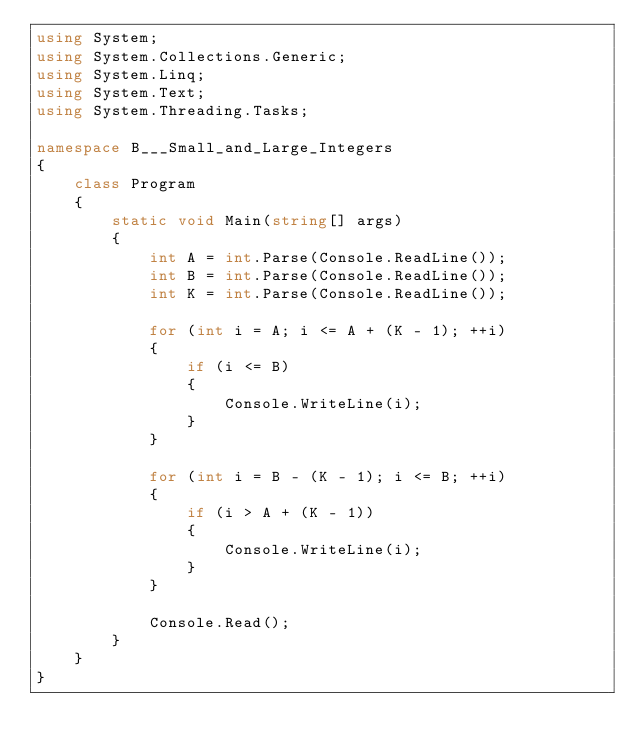Convert code to text. <code><loc_0><loc_0><loc_500><loc_500><_C#_>using System;
using System.Collections.Generic;
using System.Linq;
using System.Text;
using System.Threading.Tasks;

namespace B___Small_and_Large_Integers
{
    class Program
    {
        static void Main(string[] args)
        {
            int A = int.Parse(Console.ReadLine());
            int B = int.Parse(Console.ReadLine());
            int K = int.Parse(Console.ReadLine());

            for (int i = A; i <= A + (K - 1); ++i)
            {
                if (i <= B)
                {
                    Console.WriteLine(i);
                }
            }

            for (int i = B - (K - 1); i <= B; ++i)
            {
                if (i > A + (K - 1))
                {
                    Console.WriteLine(i);
                }
            }

            Console.Read();
        }
    }
}</code> 